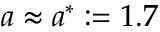<formula> <loc_0><loc_0><loc_500><loc_500>a \approx a ^ { * } \colon = 1 . 7</formula> 